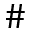<formula> <loc_0><loc_0><loc_500><loc_500>\#</formula> 